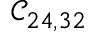<formula> <loc_0><loc_0><loc_500><loc_500>\mathcal { C } _ { 2 4 , 3 2 }</formula> 